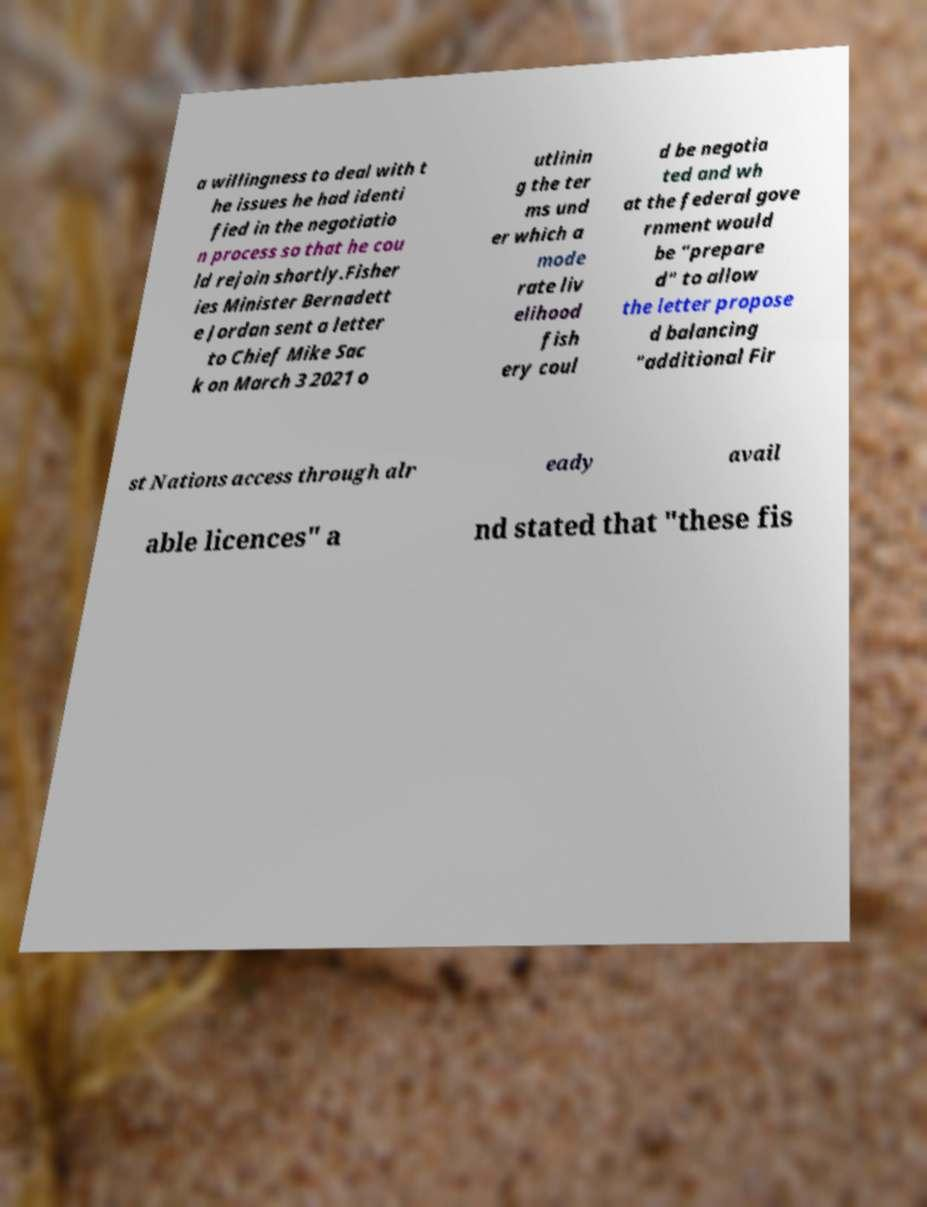Can you accurately transcribe the text from the provided image for me? a willingness to deal with t he issues he had identi fied in the negotiatio n process so that he cou ld rejoin shortly.Fisher ies Minister Bernadett e Jordan sent a letter to Chief Mike Sac k on March 3 2021 o utlinin g the ter ms und er which a mode rate liv elihood fish ery coul d be negotia ted and wh at the federal gove rnment would be "prepare d" to allow the letter propose d balancing "additional Fir st Nations access through alr eady avail able licences" a nd stated that "these fis 